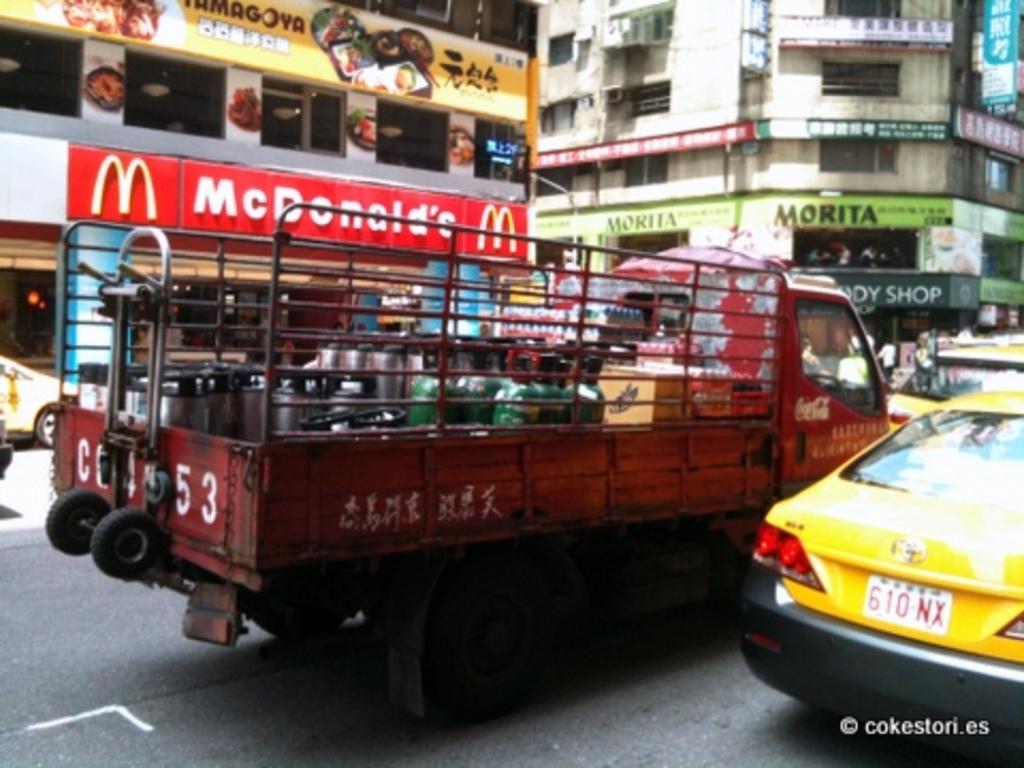What fast food company is here?
Give a very brief answer. Mcdonald's. What is the license plate number of the yellow taxi?
Keep it short and to the point. 610nx. 